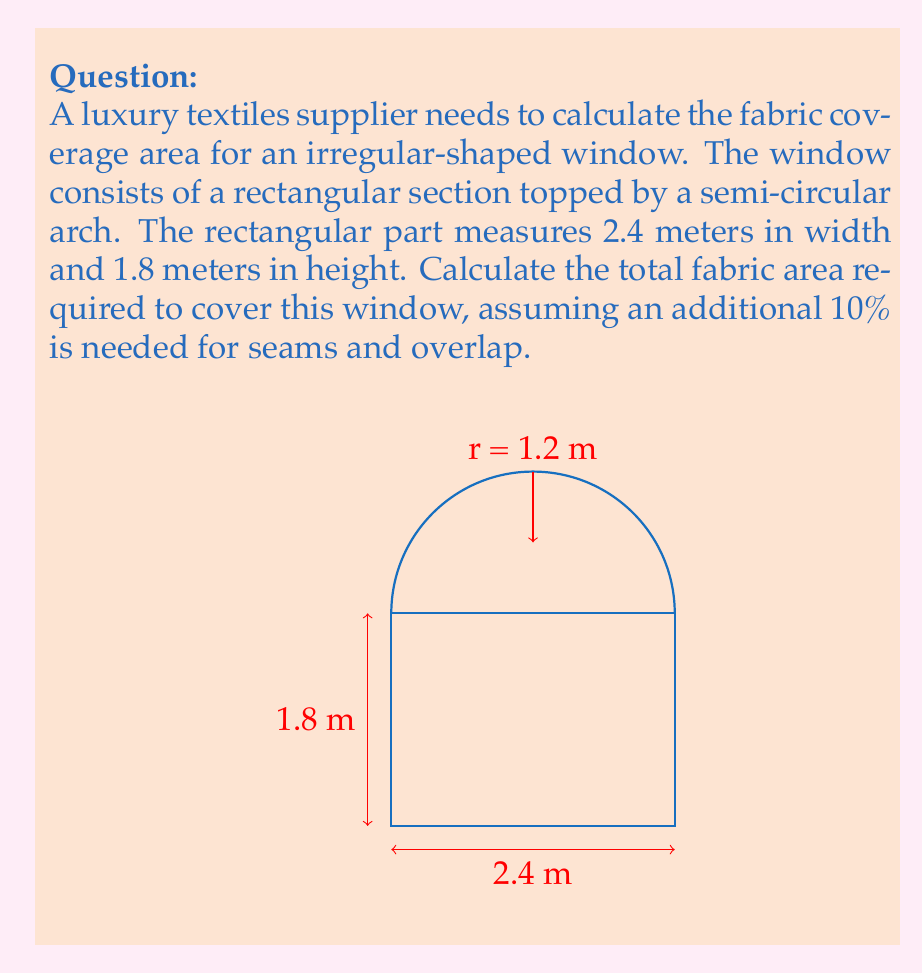Help me with this question. Let's approach this step-by-step:

1) First, we need to calculate the area of the rectangular part:
   $A_{rectangle} = width \times height = 2.4 \text{ m} \times 1.8 \text{ m} = 4.32 \text{ m}^2$

2) Next, we calculate the area of the semi-circular arch:
   The radius of the semi-circle is half the width of the rectangle: $r = 2.4 \text{ m} \div 2 = 1.2 \text{ m}$
   Area of a full circle: $A_{circle} = \pi r^2$
   Area of semi-circle: $A_{semi-circle} = \frac{1}{2} \pi r^2$
   $A_{semi-circle} = \frac{1}{2} \times \pi \times (1.2 \text{ m})^2 = 2.26 \text{ m}^2$ (rounded to 2 decimal places)

3) Total area of the window:
   $A_{total} = A_{rectangle} + A_{semi-circle} = 4.32 \text{ m}^2 + 2.26 \text{ m}^2 = 6.58 \text{ m}^2$

4) Adding 10% for seams and overlap:
   $A_{fabric} = A_{total} \times 1.10 = 6.58 \text{ m}^2 \times 1.10 = 7.238 \text{ m}^2$

Therefore, the total fabric area required is approximately 7.24 m² (rounded to 2 decimal places).
Answer: $7.24 \text{ m}^2$ 